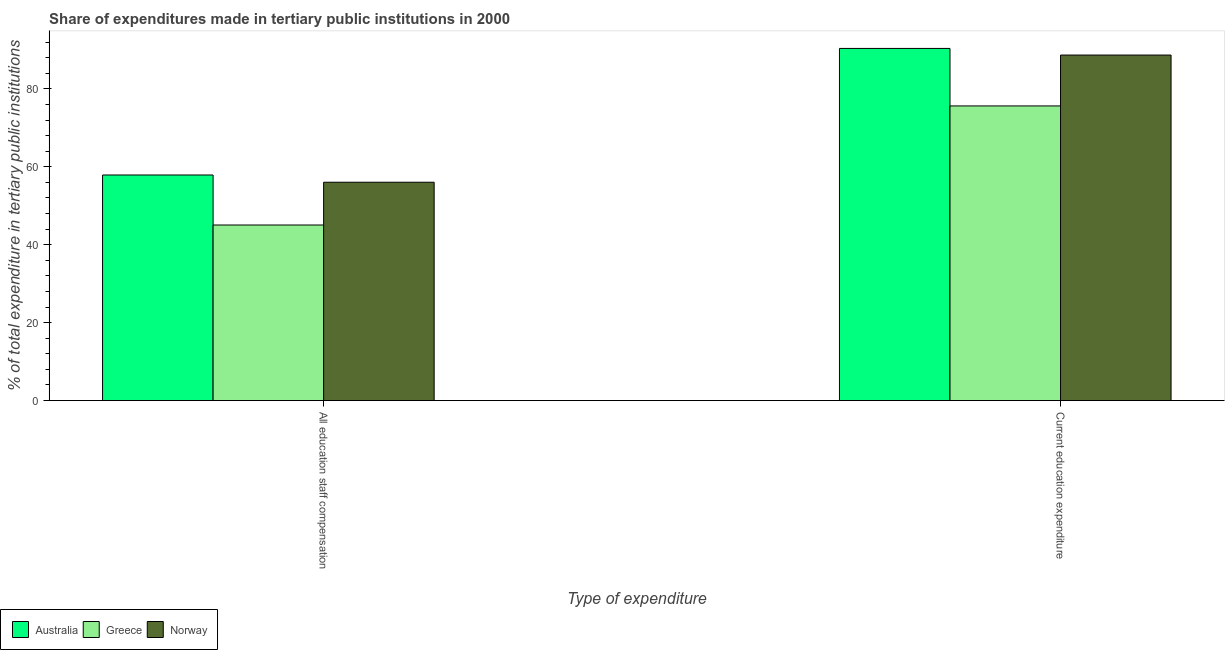How many bars are there on the 2nd tick from the right?
Provide a short and direct response. 3. What is the label of the 1st group of bars from the left?
Offer a very short reply. All education staff compensation. What is the expenditure in education in Australia?
Offer a very short reply. 90.38. Across all countries, what is the maximum expenditure in staff compensation?
Your answer should be very brief. 57.9. Across all countries, what is the minimum expenditure in staff compensation?
Keep it short and to the point. 45.06. What is the total expenditure in education in the graph?
Offer a terse response. 254.68. What is the difference between the expenditure in staff compensation in Greece and that in Norway?
Keep it short and to the point. -10.97. What is the difference between the expenditure in staff compensation in Greece and the expenditure in education in Australia?
Provide a succinct answer. -45.32. What is the average expenditure in staff compensation per country?
Ensure brevity in your answer.  53. What is the difference between the expenditure in education and expenditure in staff compensation in Australia?
Your answer should be compact. 32.48. In how many countries, is the expenditure in education greater than 76 %?
Your answer should be very brief. 2. What is the ratio of the expenditure in education in Australia to that in Greece?
Your answer should be very brief. 1.2. In how many countries, is the expenditure in staff compensation greater than the average expenditure in staff compensation taken over all countries?
Ensure brevity in your answer.  2. What does the 3rd bar from the left in All education staff compensation represents?
Provide a short and direct response. Norway. Are all the bars in the graph horizontal?
Offer a very short reply. No. What is the difference between two consecutive major ticks on the Y-axis?
Your response must be concise. 20. Are the values on the major ticks of Y-axis written in scientific E-notation?
Provide a short and direct response. No. Does the graph contain grids?
Your answer should be compact. No. What is the title of the graph?
Your answer should be very brief. Share of expenditures made in tertiary public institutions in 2000. Does "Azerbaijan" appear as one of the legend labels in the graph?
Provide a short and direct response. No. What is the label or title of the X-axis?
Make the answer very short. Type of expenditure. What is the label or title of the Y-axis?
Ensure brevity in your answer.  % of total expenditure in tertiary public institutions. What is the % of total expenditure in tertiary public institutions of Australia in All education staff compensation?
Ensure brevity in your answer.  57.9. What is the % of total expenditure in tertiary public institutions in Greece in All education staff compensation?
Your response must be concise. 45.06. What is the % of total expenditure in tertiary public institutions in Norway in All education staff compensation?
Give a very brief answer. 56.04. What is the % of total expenditure in tertiary public institutions of Australia in Current education expenditure?
Make the answer very short. 90.38. What is the % of total expenditure in tertiary public institutions in Greece in Current education expenditure?
Keep it short and to the point. 75.62. What is the % of total expenditure in tertiary public institutions in Norway in Current education expenditure?
Offer a very short reply. 88.68. Across all Type of expenditure, what is the maximum % of total expenditure in tertiary public institutions of Australia?
Ensure brevity in your answer.  90.38. Across all Type of expenditure, what is the maximum % of total expenditure in tertiary public institutions in Greece?
Make the answer very short. 75.62. Across all Type of expenditure, what is the maximum % of total expenditure in tertiary public institutions in Norway?
Provide a short and direct response. 88.68. Across all Type of expenditure, what is the minimum % of total expenditure in tertiary public institutions of Australia?
Ensure brevity in your answer.  57.9. Across all Type of expenditure, what is the minimum % of total expenditure in tertiary public institutions in Greece?
Give a very brief answer. 45.06. Across all Type of expenditure, what is the minimum % of total expenditure in tertiary public institutions in Norway?
Provide a succinct answer. 56.04. What is the total % of total expenditure in tertiary public institutions of Australia in the graph?
Provide a succinct answer. 148.27. What is the total % of total expenditure in tertiary public institutions of Greece in the graph?
Offer a terse response. 120.68. What is the total % of total expenditure in tertiary public institutions in Norway in the graph?
Keep it short and to the point. 144.72. What is the difference between the % of total expenditure in tertiary public institutions of Australia in All education staff compensation and that in Current education expenditure?
Ensure brevity in your answer.  -32.48. What is the difference between the % of total expenditure in tertiary public institutions of Greece in All education staff compensation and that in Current education expenditure?
Give a very brief answer. -30.56. What is the difference between the % of total expenditure in tertiary public institutions of Norway in All education staff compensation and that in Current education expenditure?
Keep it short and to the point. -32.65. What is the difference between the % of total expenditure in tertiary public institutions in Australia in All education staff compensation and the % of total expenditure in tertiary public institutions in Greece in Current education expenditure?
Offer a terse response. -17.72. What is the difference between the % of total expenditure in tertiary public institutions in Australia in All education staff compensation and the % of total expenditure in tertiary public institutions in Norway in Current education expenditure?
Make the answer very short. -30.78. What is the difference between the % of total expenditure in tertiary public institutions in Greece in All education staff compensation and the % of total expenditure in tertiary public institutions in Norway in Current education expenditure?
Ensure brevity in your answer.  -43.62. What is the average % of total expenditure in tertiary public institutions of Australia per Type of expenditure?
Ensure brevity in your answer.  74.14. What is the average % of total expenditure in tertiary public institutions in Greece per Type of expenditure?
Offer a very short reply. 60.34. What is the average % of total expenditure in tertiary public institutions of Norway per Type of expenditure?
Your answer should be very brief. 72.36. What is the difference between the % of total expenditure in tertiary public institutions of Australia and % of total expenditure in tertiary public institutions of Greece in All education staff compensation?
Keep it short and to the point. 12.83. What is the difference between the % of total expenditure in tertiary public institutions in Australia and % of total expenditure in tertiary public institutions in Norway in All education staff compensation?
Keep it short and to the point. 1.86. What is the difference between the % of total expenditure in tertiary public institutions in Greece and % of total expenditure in tertiary public institutions in Norway in All education staff compensation?
Keep it short and to the point. -10.97. What is the difference between the % of total expenditure in tertiary public institutions in Australia and % of total expenditure in tertiary public institutions in Greece in Current education expenditure?
Offer a very short reply. 14.76. What is the difference between the % of total expenditure in tertiary public institutions in Australia and % of total expenditure in tertiary public institutions in Norway in Current education expenditure?
Give a very brief answer. 1.7. What is the difference between the % of total expenditure in tertiary public institutions of Greece and % of total expenditure in tertiary public institutions of Norway in Current education expenditure?
Provide a succinct answer. -13.06. What is the ratio of the % of total expenditure in tertiary public institutions in Australia in All education staff compensation to that in Current education expenditure?
Your answer should be compact. 0.64. What is the ratio of the % of total expenditure in tertiary public institutions in Greece in All education staff compensation to that in Current education expenditure?
Your answer should be compact. 0.6. What is the ratio of the % of total expenditure in tertiary public institutions in Norway in All education staff compensation to that in Current education expenditure?
Your answer should be compact. 0.63. What is the difference between the highest and the second highest % of total expenditure in tertiary public institutions in Australia?
Ensure brevity in your answer.  32.48. What is the difference between the highest and the second highest % of total expenditure in tertiary public institutions in Greece?
Make the answer very short. 30.56. What is the difference between the highest and the second highest % of total expenditure in tertiary public institutions of Norway?
Give a very brief answer. 32.65. What is the difference between the highest and the lowest % of total expenditure in tertiary public institutions of Australia?
Keep it short and to the point. 32.48. What is the difference between the highest and the lowest % of total expenditure in tertiary public institutions in Greece?
Provide a short and direct response. 30.56. What is the difference between the highest and the lowest % of total expenditure in tertiary public institutions in Norway?
Provide a succinct answer. 32.65. 